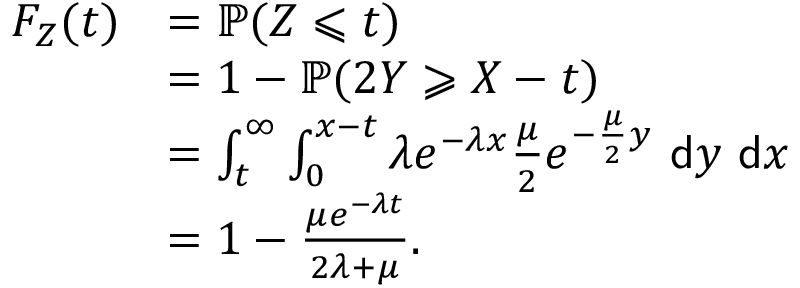Convert formula to latex. <formula><loc_0><loc_0><loc_500><loc_500>\begin{array} { r l } { F _ { Z } ( t ) } & { = \mathbb { P } ( Z \leqslant t ) } \\ & { = 1 - \mathbb { P } ( 2 Y \geqslant X - t ) } \\ & { = \int _ { t } ^ { \infty } \int _ { 0 } ^ { x - t } \lambda e ^ { - \lambda x } \frac { \mu } { 2 } e ^ { - \frac { \mu } { 2 } y } \ \mathsf d y \ \mathsf d x } \\ & { = 1 - \frac { \mu e ^ { - \lambda t } } { 2 \lambda + \mu } . } \end{array}</formula> 